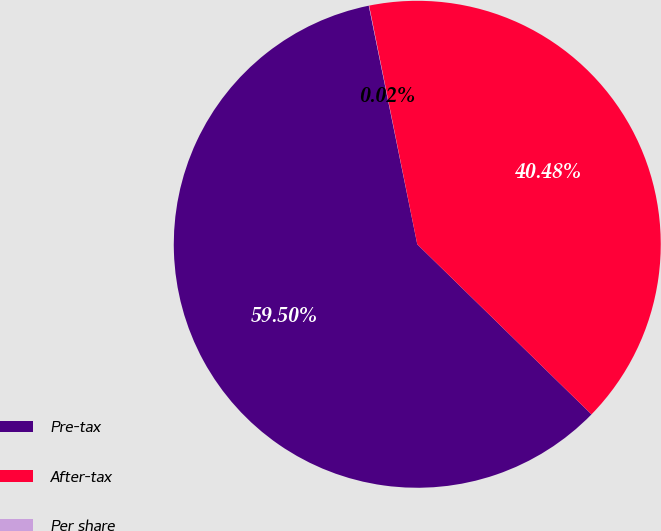Convert chart. <chart><loc_0><loc_0><loc_500><loc_500><pie_chart><fcel>Pre-tax<fcel>After-tax<fcel>Per share<nl><fcel>59.5%<fcel>40.48%<fcel>0.02%<nl></chart> 